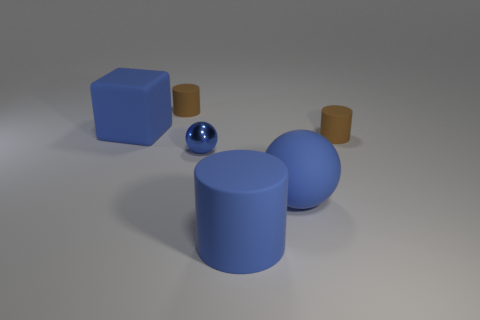There is a rubber object that is to the right of the blue rubber cylinder and in front of the small metallic thing; what is its shape?
Offer a terse response. Sphere. There is a large ball that is on the right side of the blue ball left of the rubber cylinder in front of the big ball; what color is it?
Keep it short and to the point. Blue. Are there more big matte objects that are to the left of the large blue rubber ball than large blue blocks that are to the right of the blue cube?
Your response must be concise. Yes. What number of other things are the same size as the rubber sphere?
Your answer should be compact. 2. What size is the block that is the same color as the shiny object?
Provide a short and direct response. Large. There is a small brown cylinder that is in front of the tiny thing on the left side of the small blue metal ball; what is it made of?
Ensure brevity in your answer.  Rubber. Are there any tiny cylinders to the right of the blue rubber cylinder?
Your response must be concise. Yes. Is the number of tiny things that are left of the blue metallic sphere greater than the number of large cyan shiny cylinders?
Offer a very short reply. Yes. Is there a rubber thing of the same color as the matte ball?
Ensure brevity in your answer.  Yes. What is the color of the cube that is the same size as the rubber ball?
Make the answer very short. Blue. 